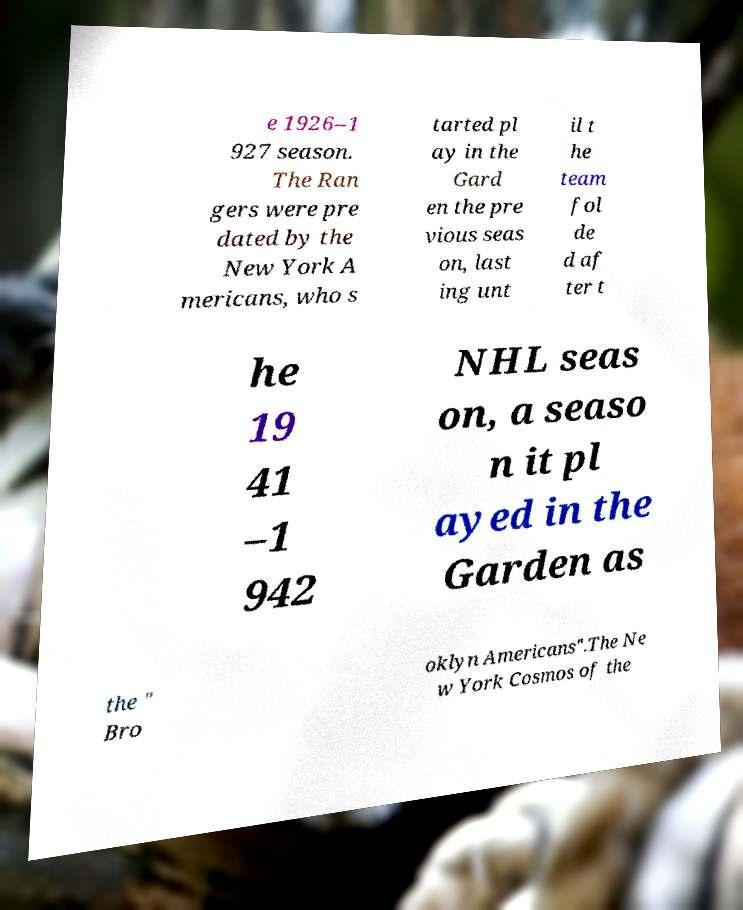Please identify and transcribe the text found in this image. e 1926–1 927 season. The Ran gers were pre dated by the New York A mericans, who s tarted pl ay in the Gard en the pre vious seas on, last ing unt il t he team fol de d af ter t he 19 41 –1 942 NHL seas on, a seaso n it pl ayed in the Garden as the " Bro oklyn Americans".The Ne w York Cosmos of the 